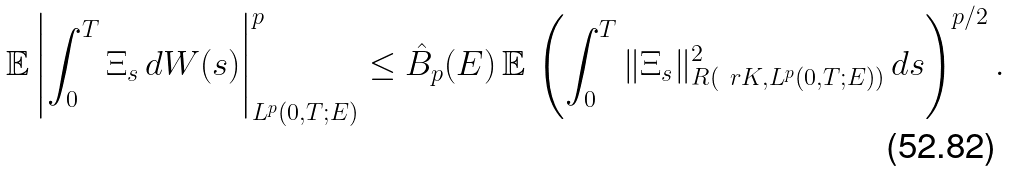<formula> <loc_0><loc_0><loc_500><loc_500>\mathbb { E } \left | \int _ { 0 } ^ { T } \Xi _ { s } \, d W ( s ) \right | _ { L ^ { p } ( 0 , T ; E ) } ^ { p } \leq \hat { B } _ { p } ( E ) \, \mathbb { E } \, \left ( \int ^ { T } _ { 0 } \| \Xi _ { s } \| _ { R ( \ r K , L ^ { p } ( 0 , T ; E ) ) } ^ { 2 } \, d s \right ) ^ { p / 2 } .</formula> 